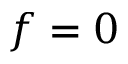Convert formula to latex. <formula><loc_0><loc_0><loc_500><loc_500>f = 0</formula> 